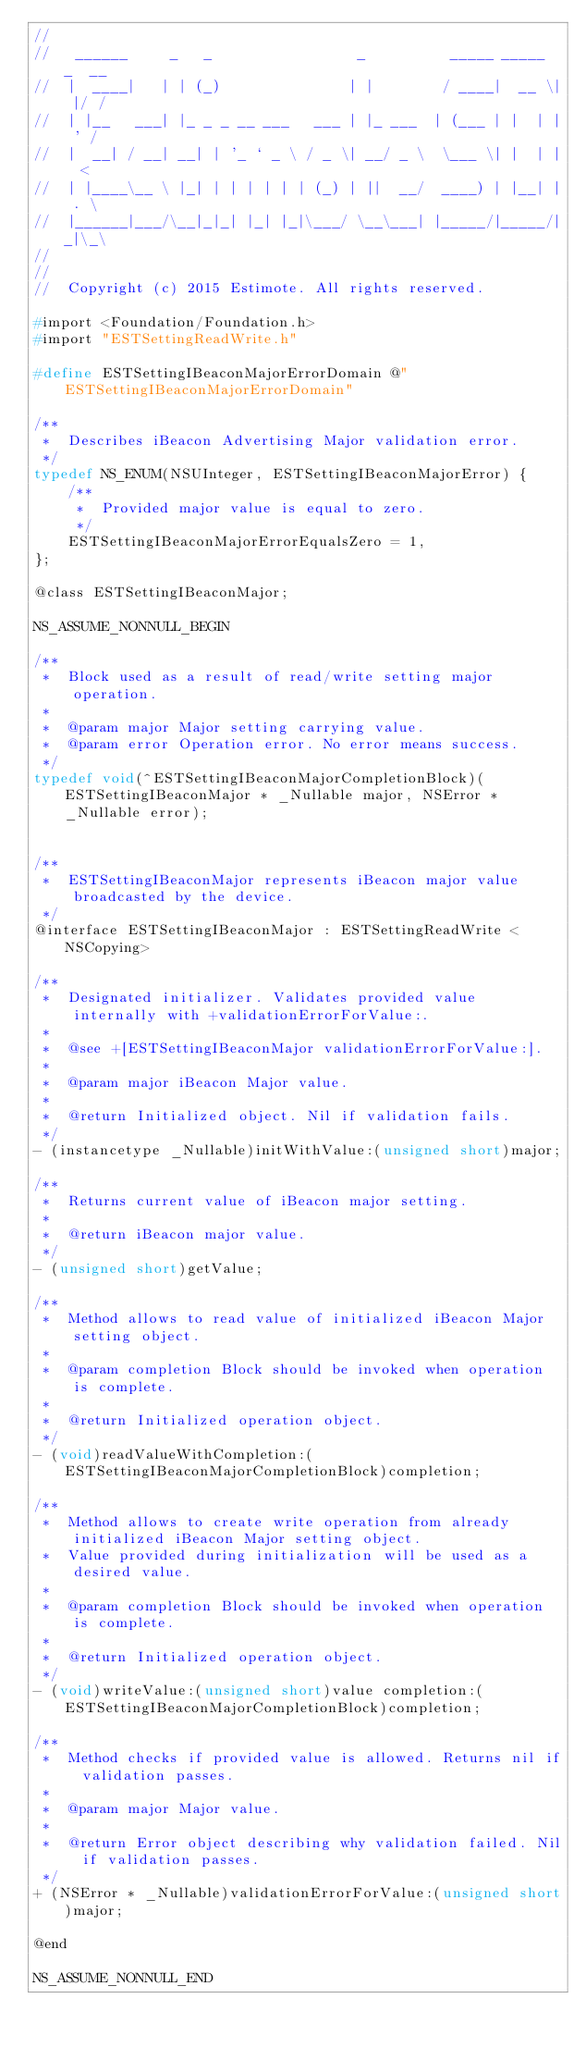<code> <loc_0><loc_0><loc_500><loc_500><_C_>//
//   ______     _   _                 _          _____ _____  _  __
//  |  ____|   | | (_)               | |        / ____|  __ \| |/ /
//  | |__   ___| |_ _ _ __ ___   ___ | |_ ___  | (___ | |  | | ' /
//  |  __| / __| __| | '_ ` _ \ / _ \| __/ _ \  \___ \| |  | |  <
//  | |____\__ \ |_| | | | | | | (_) | ||  __/  ____) | |__| | . \
//  |______|___/\__|_|_| |_| |_|\___/ \__\___| |_____/|_____/|_|\_\
//
//
//  Copyright (c) 2015 Estimote. All rights reserved.

#import <Foundation/Foundation.h>
#import "ESTSettingReadWrite.h"

#define ESTSettingIBeaconMajorErrorDomain @"ESTSettingIBeaconMajorErrorDomain"

/**
 *  Describes iBeacon Advertising Major validation error.
 */
typedef NS_ENUM(NSUInteger, ESTSettingIBeaconMajorError) {
    /**
     *  Provided major value is equal to zero.
     */
    ESTSettingIBeaconMajorErrorEqualsZero = 1,
};

@class ESTSettingIBeaconMajor;

NS_ASSUME_NONNULL_BEGIN

/**
 *  Block used as a result of read/write setting major operation.
 *
 *  @param major Major setting carrying value.
 *  @param error Operation error. No error means success.
 */
typedef void(^ESTSettingIBeaconMajorCompletionBlock)(ESTSettingIBeaconMajor * _Nullable major, NSError * _Nullable error);


/**
 *  ESTSettingIBeaconMajor represents iBeacon major value broadcasted by the device.
 */
@interface ESTSettingIBeaconMajor : ESTSettingReadWrite <NSCopying>

/**
 *  Designated initializer. Validates provided value internally with +validationErrorForValue:.
 *
 *  @see +[ESTSettingIBeaconMajor validationErrorForValue:].
 *
 *  @param major iBeacon Major value.
 *
 *  @return Initialized object. Nil if validation fails.
 */
- (instancetype _Nullable)initWithValue:(unsigned short)major;

/**
 *  Returns current value of iBeacon major setting.
 *
 *  @return iBeacon major value.
 */
- (unsigned short)getValue;

/**
 *  Method allows to read value of initialized iBeacon Major setting object.
 *
 *  @param completion Block should be invoked when operation is complete.
 *
 *  @return Initialized operation object.
 */
- (void)readValueWithCompletion:(ESTSettingIBeaconMajorCompletionBlock)completion;

/**
 *  Method allows to create write operation from already initialized iBeacon Major setting object.
 *  Value provided during initialization will be used as a desired value.
 *
 *  @param completion Block should be invoked when operation is complete.
 *
 *  @return Initialized operation object.
 */
- (void)writeValue:(unsigned short)value completion:(ESTSettingIBeaconMajorCompletionBlock)completion;

/**
 *  Method checks if provided value is allowed. Returns nil if validation passes.
 *
 *  @param major Major value.
 *
 *  @return Error object describing why validation failed. Nil if validation passes.
 */
+ (NSError * _Nullable)validationErrorForValue:(unsigned short)major;

@end

NS_ASSUME_NONNULL_END
</code> 